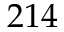Convert formula to latex. <formula><loc_0><loc_0><loc_500><loc_500>2 1 4</formula> 